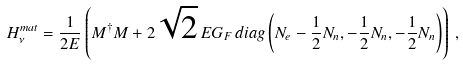<formula> <loc_0><loc_0><loc_500><loc_500>H _ { \nu } ^ { m a t } = \frac { 1 } { 2 E } \left ( M ^ { \dagger } M + 2 \sqrt { 2 } \, E G _ { F } \, d i a g \left ( N _ { e } - \frac { 1 } { 2 } N _ { n } , - \frac { 1 } { 2 } N _ { n } , - \frac { 1 } { 2 } N _ { n } \right ) \right ) \, ,</formula> 